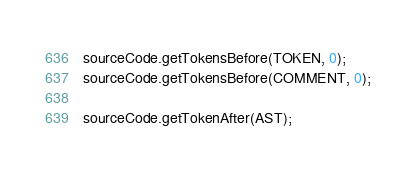Convert code to text. <code><loc_0><loc_0><loc_500><loc_500><_TypeScript_>sourceCode.getTokensBefore(TOKEN, 0);
sourceCode.getTokensBefore(COMMENT, 0);

sourceCode.getTokenAfter(AST);</code> 